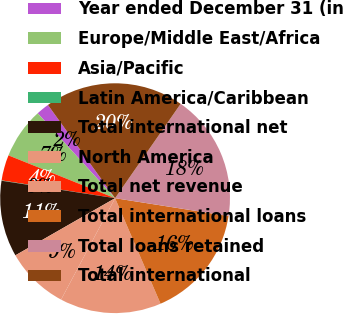Convert chart to OTSL. <chart><loc_0><loc_0><loc_500><loc_500><pie_chart><fcel>Year ended December 31 (in<fcel>Europe/Middle East/Africa<fcel>Asia/Pacific<fcel>Latin America/Caribbean<fcel>Total international net<fcel>North America<fcel>Total net revenue<fcel>Total international loans<fcel>Total loans retained<fcel>Total international<nl><fcel>1.83%<fcel>7.16%<fcel>3.6%<fcel>0.05%<fcel>10.71%<fcel>8.93%<fcel>14.26%<fcel>16.04%<fcel>17.82%<fcel>19.6%<nl></chart> 